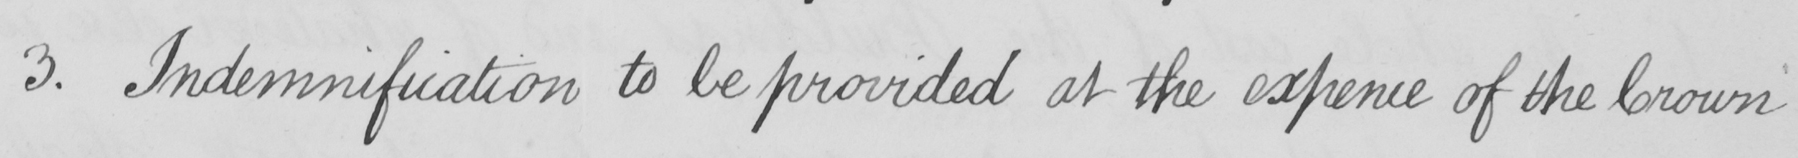Please provide the text content of this handwritten line. 3 . Indemnification to be provided at the expence of the Crown 